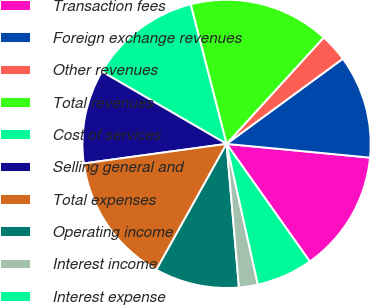Convert chart. <chart><loc_0><loc_0><loc_500><loc_500><pie_chart><fcel>Transaction fees<fcel>Foreign exchange revenues<fcel>Other revenues<fcel>Total revenues<fcel>Cost of services<fcel>Selling general and<fcel>Total expenses<fcel>Operating income<fcel>Interest income<fcel>Interest expense<nl><fcel>13.68%<fcel>11.58%<fcel>3.16%<fcel>15.79%<fcel>12.63%<fcel>10.53%<fcel>14.74%<fcel>9.47%<fcel>2.11%<fcel>6.32%<nl></chart> 